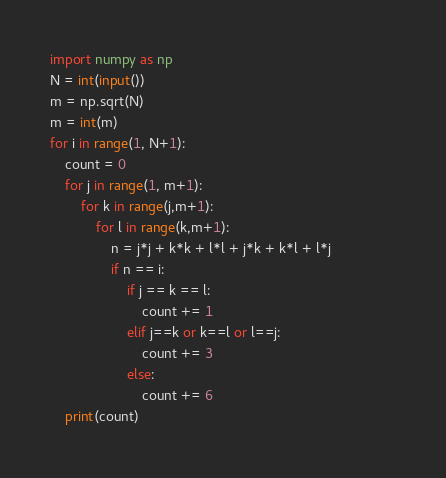<code> <loc_0><loc_0><loc_500><loc_500><_Python_>import numpy as np
N = int(input())
m = np.sqrt(N)
m = int(m)
for i in range(1, N+1):
    count = 0
    for j in range(1, m+1):
        for k in range(j,m+1):
            for l in range(k,m+1):
                n = j*j + k*k + l*l + j*k + k*l + l*j                 
                if n == i:
                    if j == k == l:
                        count += 1
                    elif j==k or k==l or l==j:
                        count += 3
                    else:
                        count += 6
    print(count)    </code> 